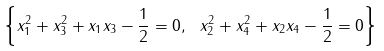Convert formula to latex. <formula><loc_0><loc_0><loc_500><loc_500>\left \{ x _ { 1 } ^ { 2 } + x _ { 3 } ^ { 2 } + x _ { 1 } x _ { 3 } - \frac { 1 } { 2 } = 0 , \ x _ { 2 } ^ { 2 } + x _ { 4 } ^ { 2 } + x _ { 2 } x _ { 4 } - \frac { 1 } { 2 } = 0 \right \}</formula> 